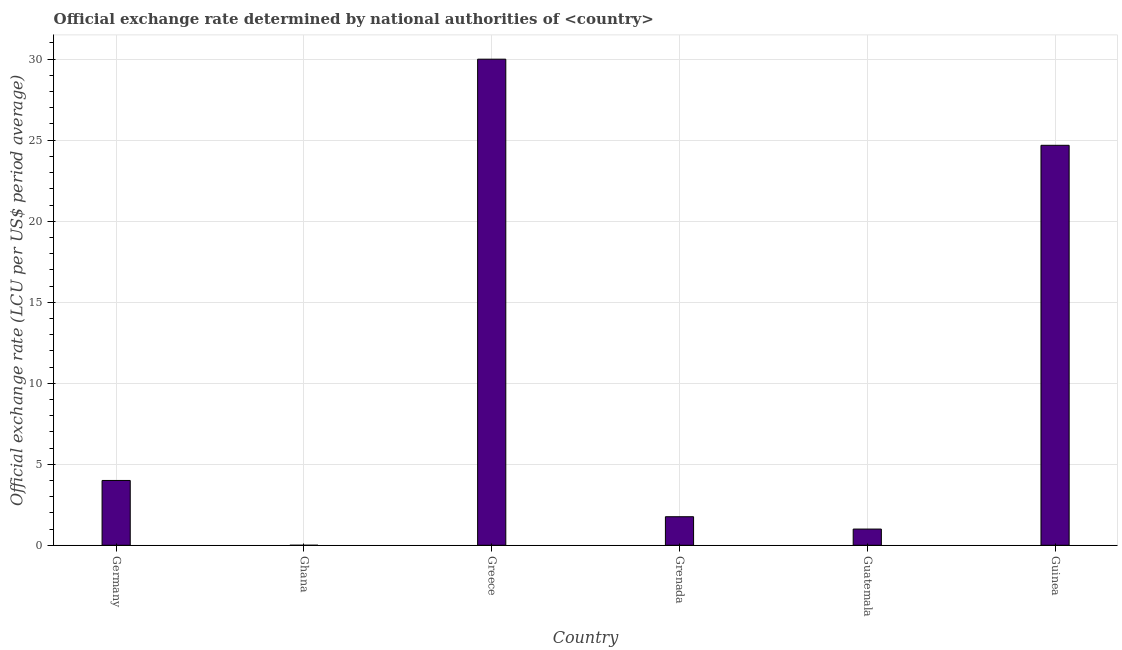What is the title of the graph?
Your response must be concise. Official exchange rate determined by national authorities of <country>. What is the label or title of the Y-axis?
Provide a short and direct response. Official exchange rate (LCU per US$ period average). What is the official exchange rate in Ghana?
Ensure brevity in your answer.  8.608119479252691e-5. Across all countries, what is the maximum official exchange rate?
Give a very brief answer. 30. Across all countries, what is the minimum official exchange rate?
Your answer should be very brief. 8.608119479252691e-5. In which country was the official exchange rate maximum?
Ensure brevity in your answer.  Greece. What is the sum of the official exchange rate?
Provide a succinct answer. 61.45. What is the difference between the official exchange rate in Greece and Grenada?
Your answer should be compact. 28.24. What is the average official exchange rate per country?
Keep it short and to the point. 10.24. What is the median official exchange rate?
Provide a short and direct response. 2.88. What is the ratio of the official exchange rate in Greece to that in Guinea?
Your response must be concise. 1.22. Is the official exchange rate in Germany less than that in Guatemala?
Keep it short and to the point. No. What is the difference between the highest and the second highest official exchange rate?
Make the answer very short. 5.32. In how many countries, is the official exchange rate greater than the average official exchange rate taken over all countries?
Keep it short and to the point. 2. How many bars are there?
Offer a terse response. 6. Are all the bars in the graph horizontal?
Keep it short and to the point. No. Are the values on the major ticks of Y-axis written in scientific E-notation?
Offer a terse response. No. What is the Official exchange rate (LCU per US$ period average) in Germany?
Give a very brief answer. 4. What is the Official exchange rate (LCU per US$ period average) in Ghana?
Provide a succinct answer. 8.608119479252691e-5. What is the Official exchange rate (LCU per US$ period average) of Greece?
Provide a succinct answer. 30. What is the Official exchange rate (LCU per US$ period average) in Grenada?
Provide a succinct answer. 1.76. What is the Official exchange rate (LCU per US$ period average) of Guatemala?
Provide a short and direct response. 1. What is the Official exchange rate (LCU per US$ period average) in Guinea?
Offer a terse response. 24.69. What is the difference between the Official exchange rate (LCU per US$ period average) in Germany and Ghana?
Keep it short and to the point. 4. What is the difference between the Official exchange rate (LCU per US$ period average) in Germany and Grenada?
Offer a very short reply. 2.24. What is the difference between the Official exchange rate (LCU per US$ period average) in Germany and Guatemala?
Your response must be concise. 3. What is the difference between the Official exchange rate (LCU per US$ period average) in Germany and Guinea?
Your response must be concise. -20.68. What is the difference between the Official exchange rate (LCU per US$ period average) in Ghana and Greece?
Keep it short and to the point. -30. What is the difference between the Official exchange rate (LCU per US$ period average) in Ghana and Grenada?
Give a very brief answer. -1.76. What is the difference between the Official exchange rate (LCU per US$ period average) in Ghana and Guatemala?
Offer a terse response. -1. What is the difference between the Official exchange rate (LCU per US$ period average) in Ghana and Guinea?
Ensure brevity in your answer.  -24.68. What is the difference between the Official exchange rate (LCU per US$ period average) in Greece and Grenada?
Provide a short and direct response. 28.24. What is the difference between the Official exchange rate (LCU per US$ period average) in Greece and Guinea?
Ensure brevity in your answer.  5.32. What is the difference between the Official exchange rate (LCU per US$ period average) in Grenada and Guatemala?
Your response must be concise. 0.76. What is the difference between the Official exchange rate (LCU per US$ period average) in Grenada and Guinea?
Offer a very short reply. -22.92. What is the difference between the Official exchange rate (LCU per US$ period average) in Guatemala and Guinea?
Ensure brevity in your answer.  -23.68. What is the ratio of the Official exchange rate (LCU per US$ period average) in Germany to that in Ghana?
Offer a very short reply. 4.65e+04. What is the ratio of the Official exchange rate (LCU per US$ period average) in Germany to that in Greece?
Provide a succinct answer. 0.13. What is the ratio of the Official exchange rate (LCU per US$ period average) in Germany to that in Grenada?
Offer a very short reply. 2.27. What is the ratio of the Official exchange rate (LCU per US$ period average) in Germany to that in Guinea?
Make the answer very short. 0.16. What is the ratio of the Official exchange rate (LCU per US$ period average) in Ghana to that in Grenada?
Provide a short and direct response. 0. What is the ratio of the Official exchange rate (LCU per US$ period average) in Greece to that in Grenada?
Provide a succinct answer. 17.03. What is the ratio of the Official exchange rate (LCU per US$ period average) in Greece to that in Guinea?
Make the answer very short. 1.22. What is the ratio of the Official exchange rate (LCU per US$ period average) in Grenada to that in Guatemala?
Provide a succinct answer. 1.76. What is the ratio of the Official exchange rate (LCU per US$ period average) in Grenada to that in Guinea?
Your answer should be very brief. 0.07. What is the ratio of the Official exchange rate (LCU per US$ period average) in Guatemala to that in Guinea?
Ensure brevity in your answer.  0.04. 